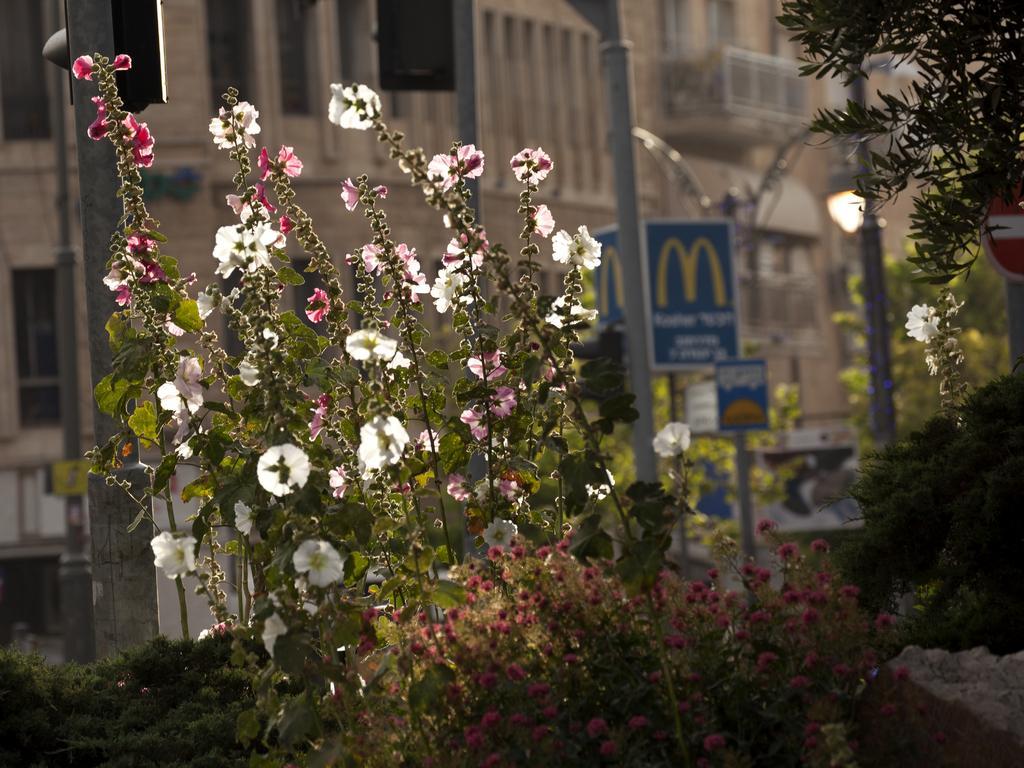How would you summarize this image in a sentence or two? In this image there are plants and we can see flowers. In the background there are buildings and we can see boards. There are poles. 